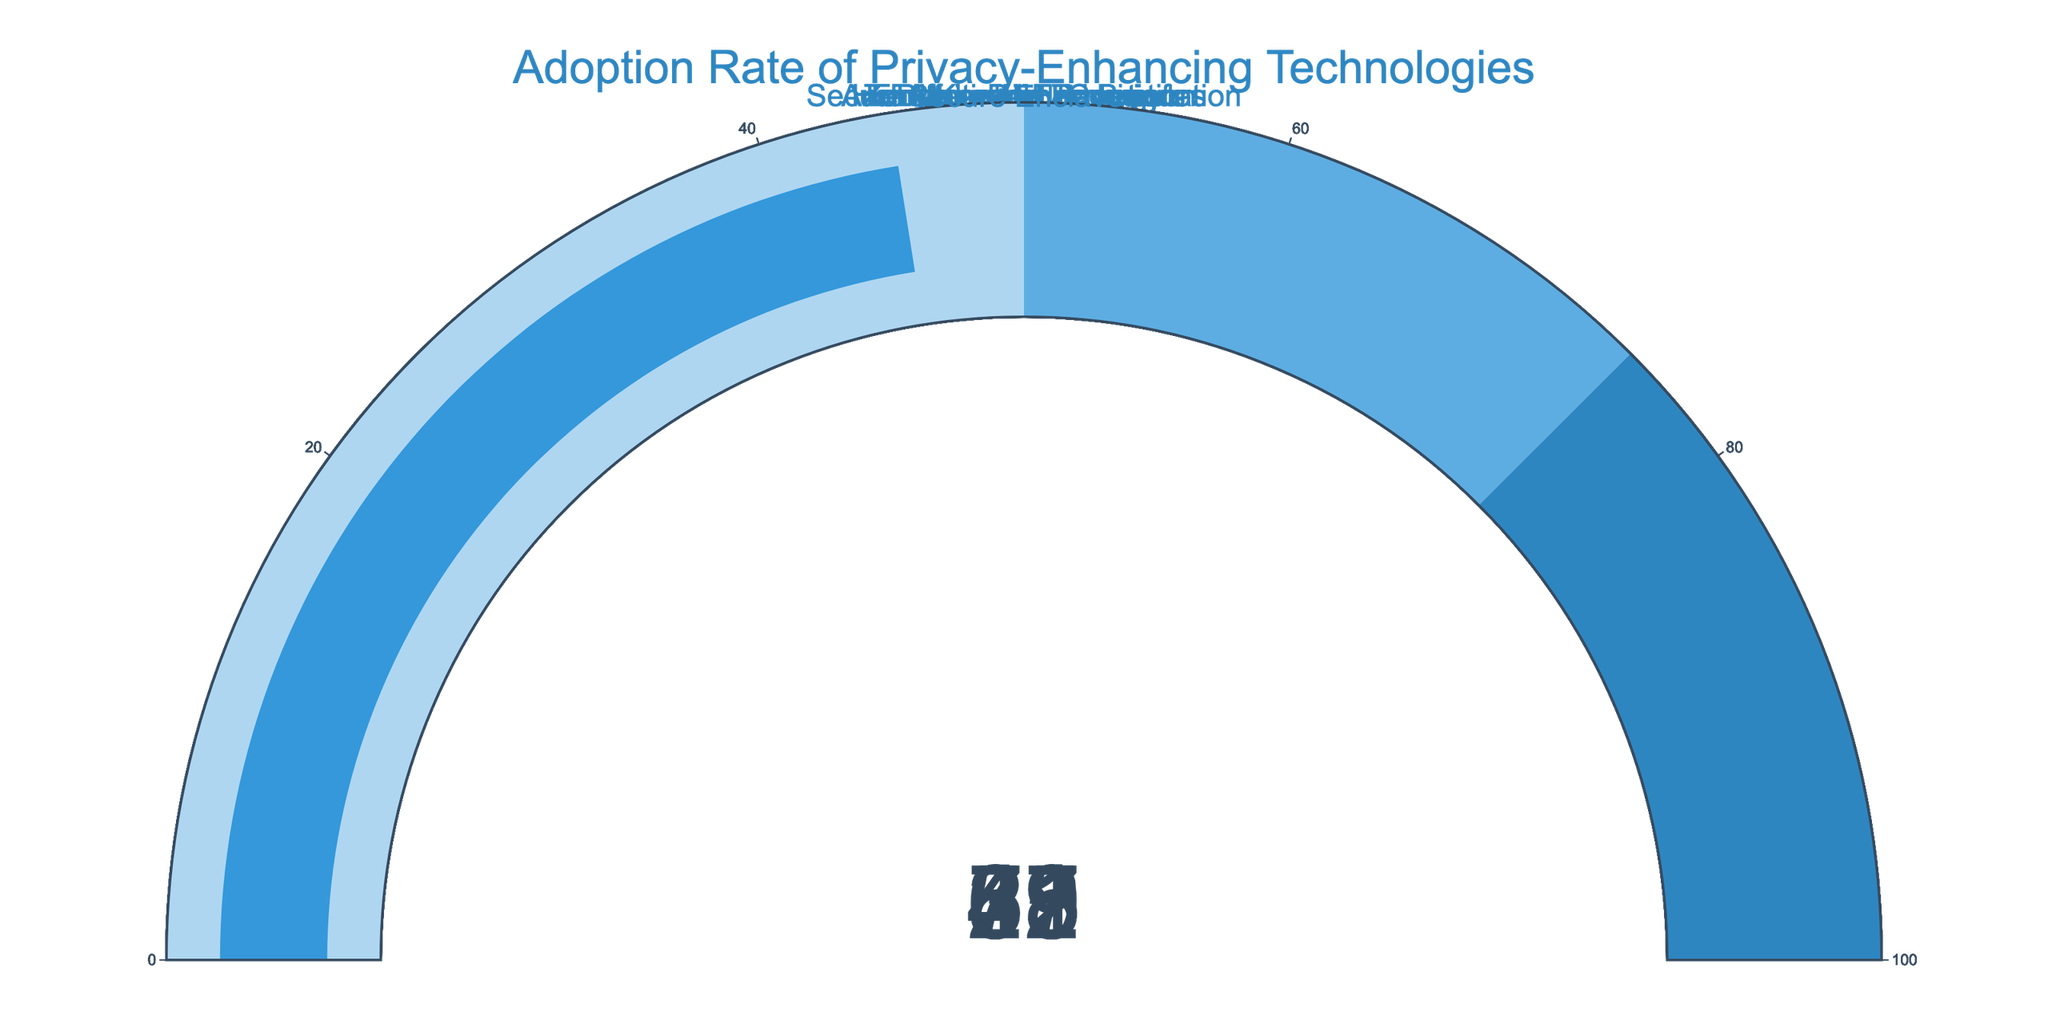Which technology has the highest adoption rate? The technology with the highest adoption rate can be identified by finding the gauge with the highest number displayed. End-to-end Encryption has the highest value at 78.
Answer: End-to-end Encryption What's the difference in adoption rate between Differential Privacy and Homomorphic Encryption? Subtract the adoption rate of Homomorphic Encryption (23) from that of Differential Privacy (42). 42 - 23 = 19.
Answer: 19 What is the average adoption rate of Federated Learning, Secure Enclaves, and Anonymization Techniques? Sum the adoption rates of Federated Learning (51), Secure Enclaves (45), and Anonymization Techniques (67), then divide by 3. (51 + 45 + 67) / 3 = 163 / 3 ≈ 54.33.
Answer: 54.33 Which technology has an adoption rate closest to but not exceeding 50? Find the closest adoption rate to 50 without exceeding it. Secure Enclaves has an adoption rate of 45, which is closest without exceeding 50.
Answer: Secure Enclaves How much greater is the adoption rate of End-to-end Encryption compared to Secure Multi-Party Computation? Subtract the adoption rate of Secure Multi-Party Computation (35) from that of End-to-end Encryption (78). 78 - 35 = 43.
Answer: 43 Which technologies have an adoption rate above 50? Identify all gauges displaying a number greater than 50. End-to-end Encryption (78), Anonymization Techniques (67), and Federated Learning (51).
Answer: End-to-end Encryption, Anonymization Techniques, Federated Learning Which privacy-enhancing technology has the lowest adoption rate? The technology with the lowest adoption rate can be identified by finding the gauge with the lowest number displayed. Homomorphic Encryption has the lowest value at 23.
Answer: Homomorphic Encryption Is the adoption rate of Zero-Knowledge Proofs higher than that of Secure Enclaves? Compare the gauge values for Zero-Knowledge Proofs (29) and Secure Enclaves (45). 29 is less than 45.
Answer: No What is the sum of the adoption rates of Differential Privacy and Homomorphic Encryption? Add the adoption rates of Differential Privacy (42) and Homomorphic Encryption (23). 42 + 23 = 65.
Answer: 65 How many technologies have an adoption rate of 35 or less? Count the number of gauges with values 35 or below. Differential Privacy (42), Zero-Knowledge Proofs (29), Homomorphic Encryption (23), and Secure Multi-Party Computation (35)—4 technologies.
Answer: 4 